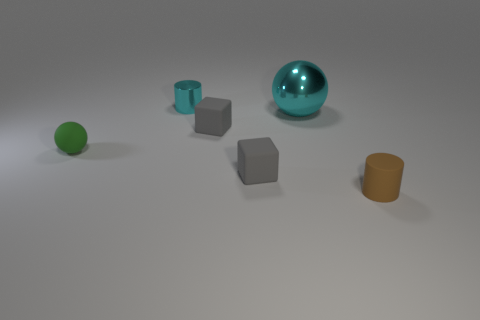Add 3 brown matte cylinders. How many objects exist? 9 Subtract all blocks. How many objects are left? 4 Subtract all gray matte cubes. Subtract all tiny gray matte cubes. How many objects are left? 2 Add 3 cyan things. How many cyan things are left? 5 Add 4 big green matte spheres. How many big green matte spheres exist? 4 Subtract 1 cyan cylinders. How many objects are left? 5 